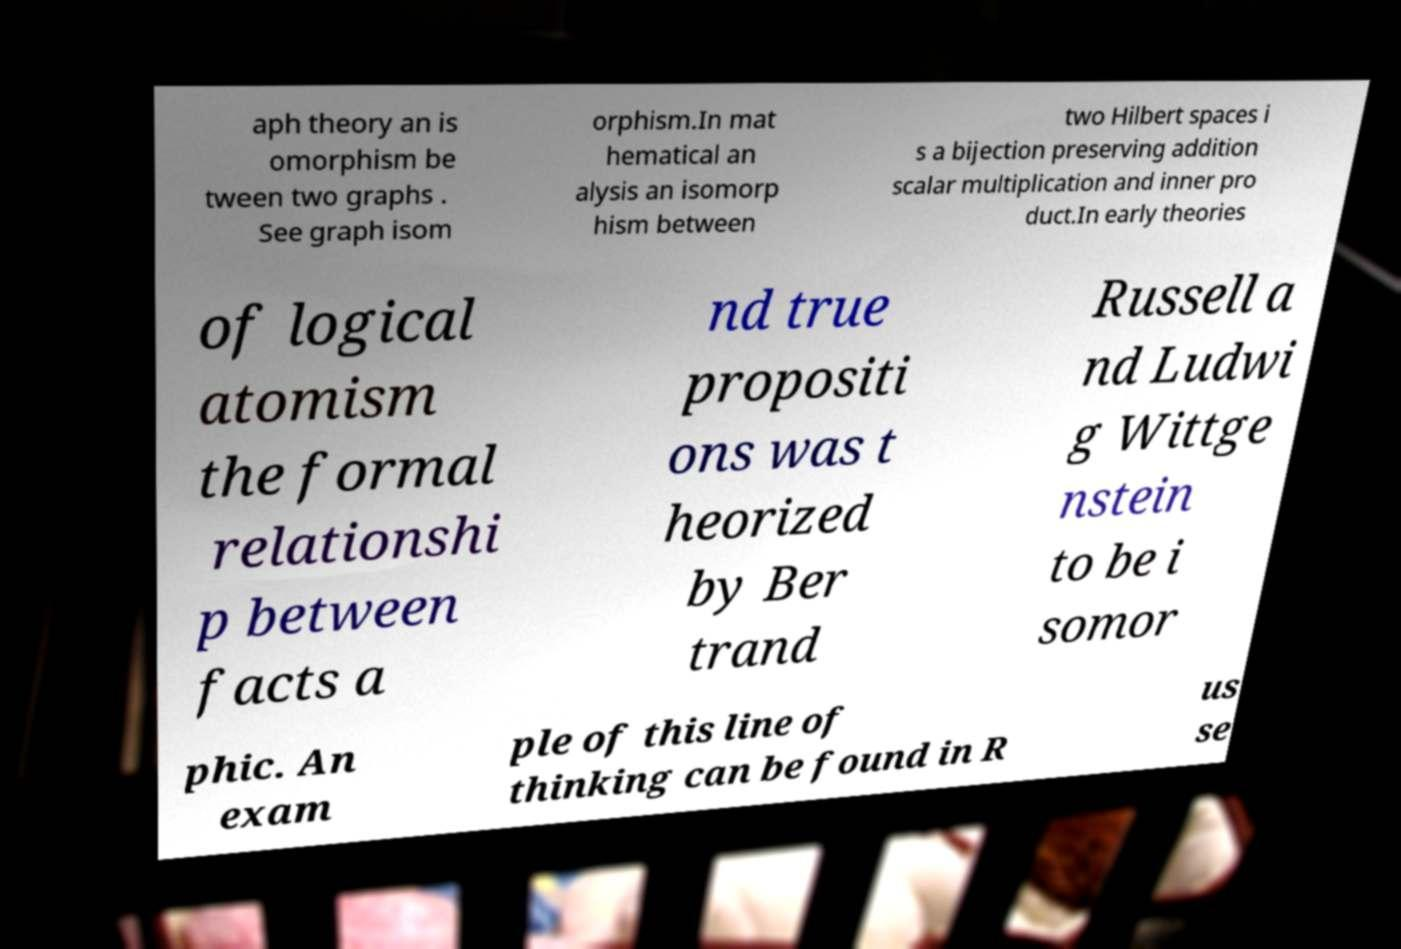Could you assist in decoding the text presented in this image and type it out clearly? aph theory an is omorphism be tween two graphs . See graph isom orphism.In mat hematical an alysis an isomorp hism between two Hilbert spaces i s a bijection preserving addition scalar multiplication and inner pro duct.In early theories of logical atomism the formal relationshi p between facts a nd true propositi ons was t heorized by Ber trand Russell a nd Ludwi g Wittge nstein to be i somor phic. An exam ple of this line of thinking can be found in R us se 